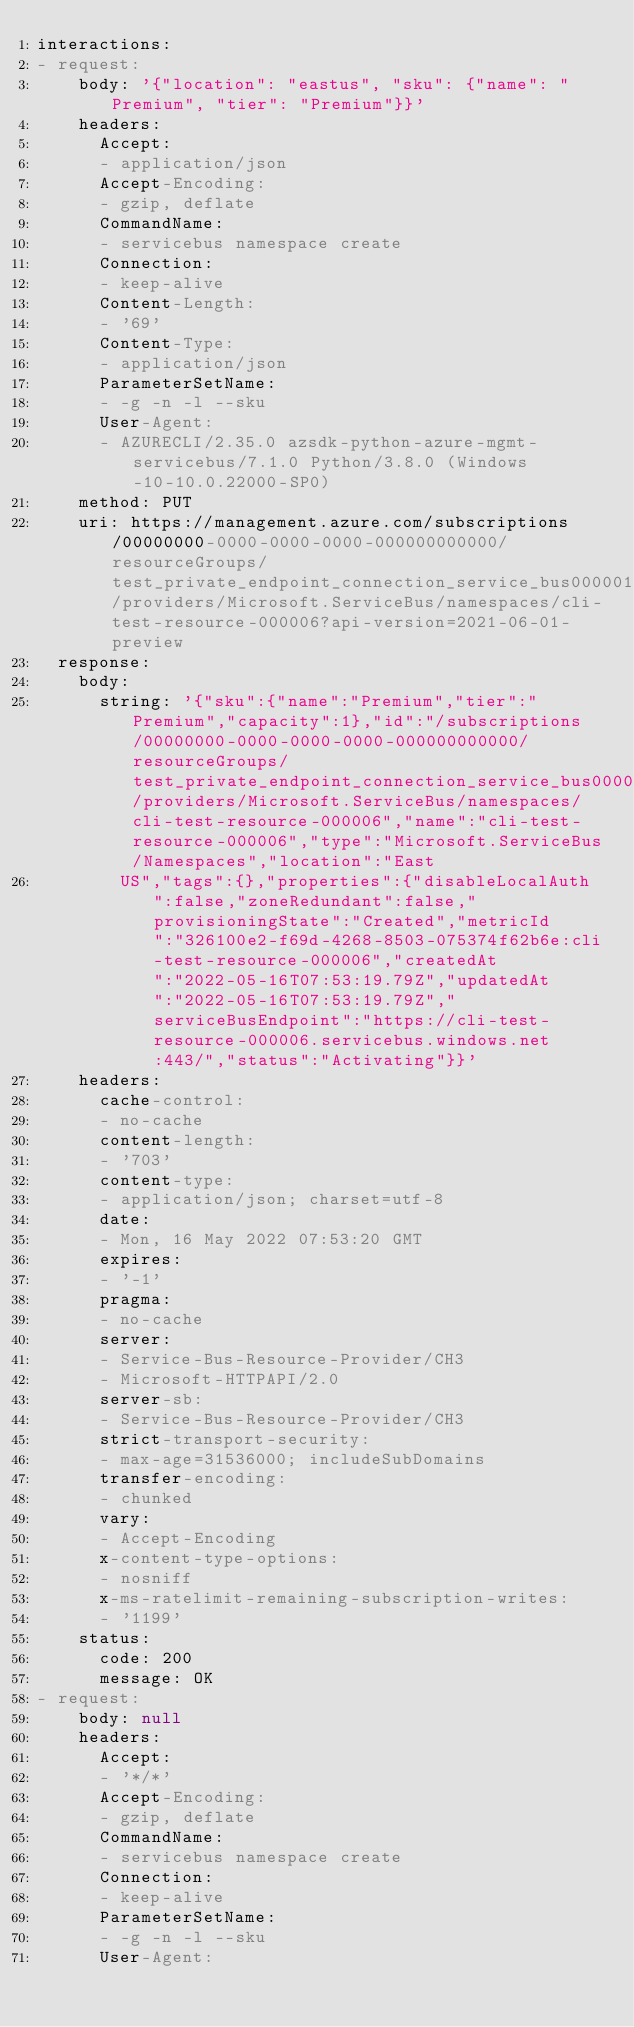Convert code to text. <code><loc_0><loc_0><loc_500><loc_500><_YAML_>interactions:
- request:
    body: '{"location": "eastus", "sku": {"name": "Premium", "tier": "Premium"}}'
    headers:
      Accept:
      - application/json
      Accept-Encoding:
      - gzip, deflate
      CommandName:
      - servicebus namespace create
      Connection:
      - keep-alive
      Content-Length:
      - '69'
      Content-Type:
      - application/json
      ParameterSetName:
      - -g -n -l --sku
      User-Agent:
      - AZURECLI/2.35.0 azsdk-python-azure-mgmt-servicebus/7.1.0 Python/3.8.0 (Windows-10-10.0.22000-SP0)
    method: PUT
    uri: https://management.azure.com/subscriptions/00000000-0000-0000-0000-000000000000/resourceGroups/test_private_endpoint_connection_service_bus000001/providers/Microsoft.ServiceBus/namespaces/cli-test-resource-000006?api-version=2021-06-01-preview
  response:
    body:
      string: '{"sku":{"name":"Premium","tier":"Premium","capacity":1},"id":"/subscriptions/00000000-0000-0000-0000-000000000000/resourceGroups/test_private_endpoint_connection_service_bus000001/providers/Microsoft.ServiceBus/namespaces/cli-test-resource-000006","name":"cli-test-resource-000006","type":"Microsoft.ServiceBus/Namespaces","location":"East
        US","tags":{},"properties":{"disableLocalAuth":false,"zoneRedundant":false,"provisioningState":"Created","metricId":"326100e2-f69d-4268-8503-075374f62b6e:cli-test-resource-000006","createdAt":"2022-05-16T07:53:19.79Z","updatedAt":"2022-05-16T07:53:19.79Z","serviceBusEndpoint":"https://cli-test-resource-000006.servicebus.windows.net:443/","status":"Activating"}}'
    headers:
      cache-control:
      - no-cache
      content-length:
      - '703'
      content-type:
      - application/json; charset=utf-8
      date:
      - Mon, 16 May 2022 07:53:20 GMT
      expires:
      - '-1'
      pragma:
      - no-cache
      server:
      - Service-Bus-Resource-Provider/CH3
      - Microsoft-HTTPAPI/2.0
      server-sb:
      - Service-Bus-Resource-Provider/CH3
      strict-transport-security:
      - max-age=31536000; includeSubDomains
      transfer-encoding:
      - chunked
      vary:
      - Accept-Encoding
      x-content-type-options:
      - nosniff
      x-ms-ratelimit-remaining-subscription-writes:
      - '1199'
    status:
      code: 200
      message: OK
- request:
    body: null
    headers:
      Accept:
      - '*/*'
      Accept-Encoding:
      - gzip, deflate
      CommandName:
      - servicebus namespace create
      Connection:
      - keep-alive
      ParameterSetName:
      - -g -n -l --sku
      User-Agent:</code> 